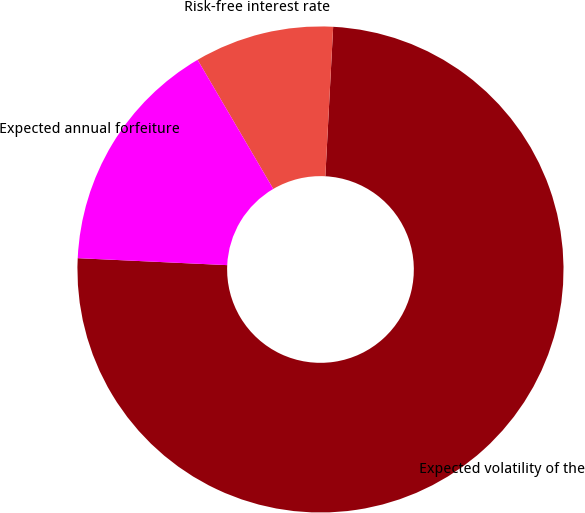Convert chart to OTSL. <chart><loc_0><loc_0><loc_500><loc_500><pie_chart><fcel>Expected volatility of the<fcel>Risk-free interest rate<fcel>Expected annual forfeiture<nl><fcel>74.91%<fcel>9.27%<fcel>15.82%<nl></chart> 